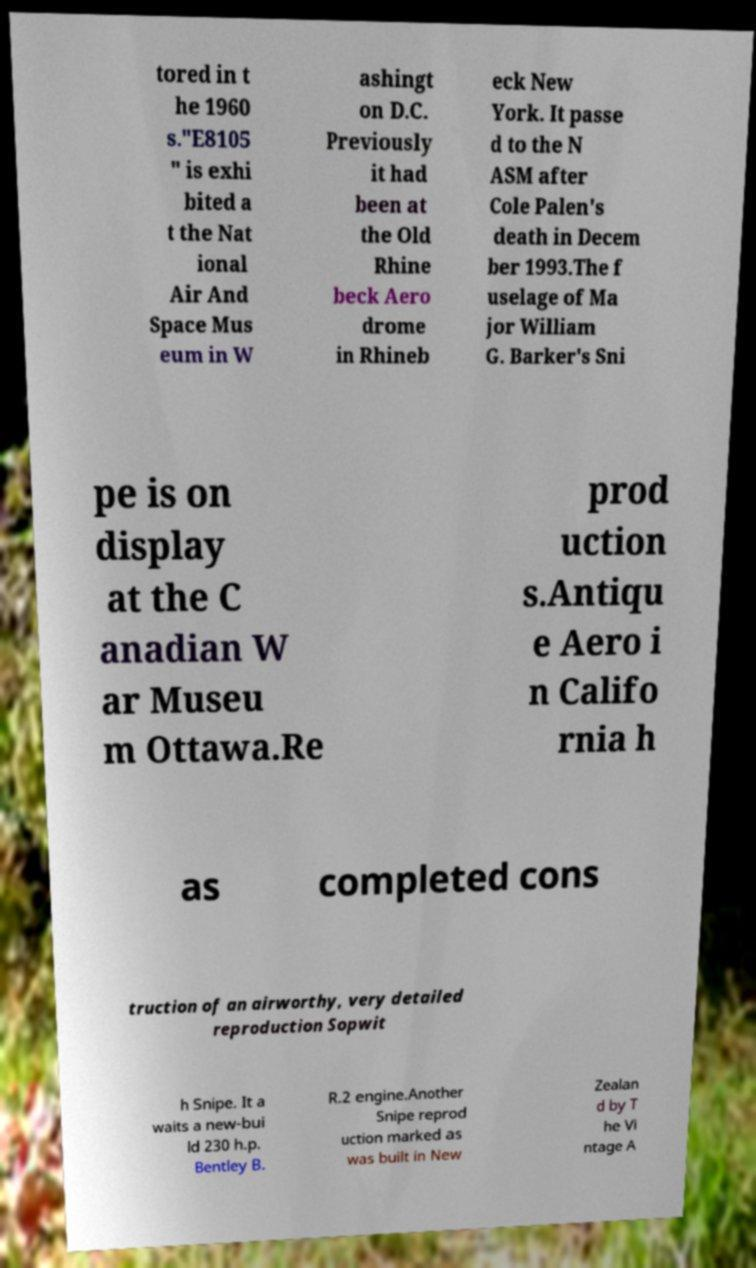Could you assist in decoding the text presented in this image and type it out clearly? tored in t he 1960 s."E8105 " is exhi bited a t the Nat ional Air And Space Mus eum in W ashingt on D.C. Previously it had been at the Old Rhine beck Aero drome in Rhineb eck New York. It passe d to the N ASM after Cole Palen's death in Decem ber 1993.The f uselage of Ma jor William G. Barker's Sni pe is on display at the C anadian W ar Museu m Ottawa.Re prod uction s.Antiqu e Aero i n Califo rnia h as completed cons truction of an airworthy, very detailed reproduction Sopwit h Snipe. It a waits a new-bui ld 230 h.p. Bentley B. R.2 engine.Another Snipe reprod uction marked as was built in New Zealan d by T he Vi ntage A 